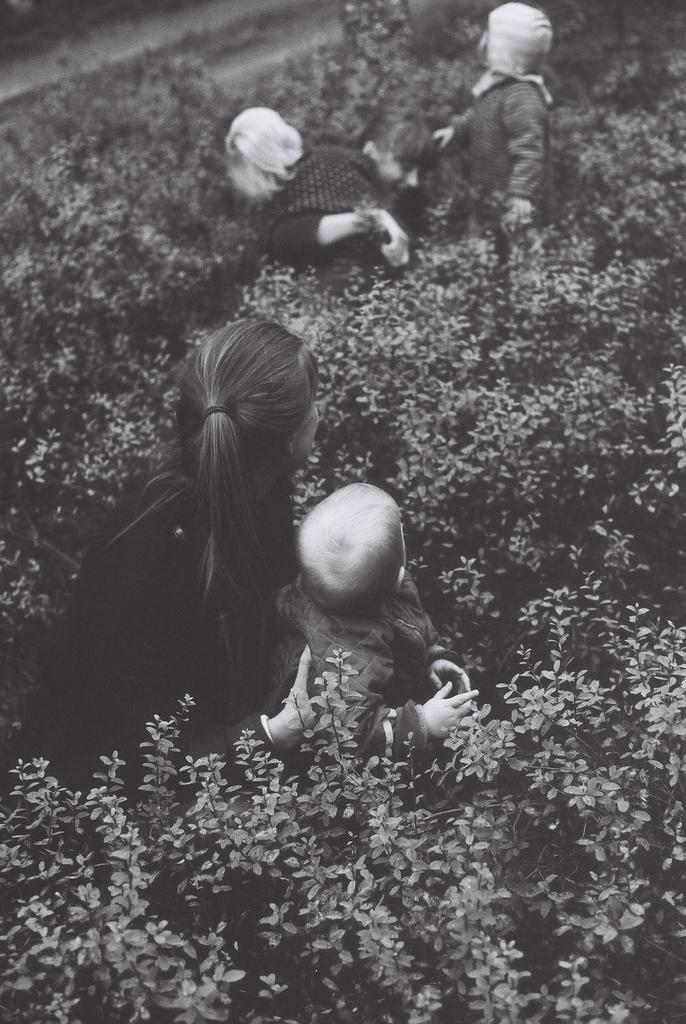Could you give a brief overview of what you see in this image? In this image I can see group of people and I can see few plants and the image is in black and white. 